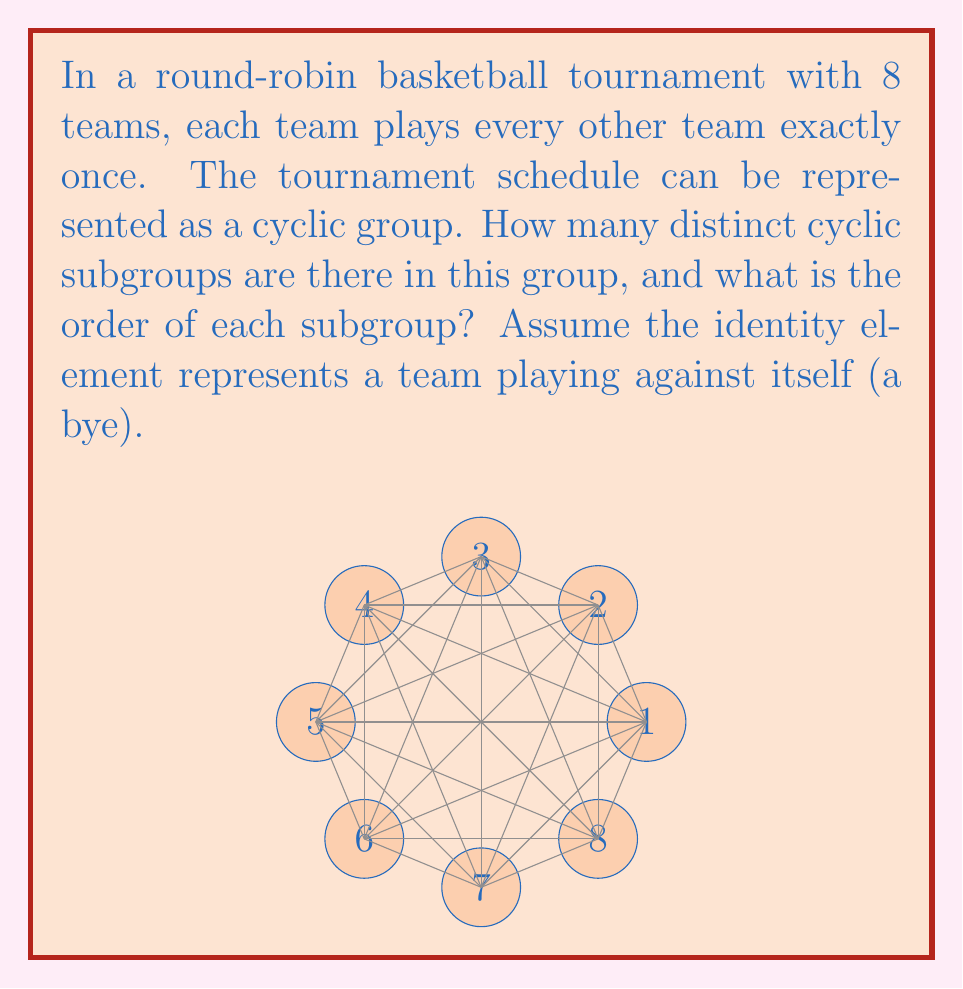Give your solution to this math problem. Let's approach this step-by-step:

1) In a round-robin tournament with 8 teams, we have a total of $\binom{8}{2} = 28$ matches.

2) The cyclic group representing this schedule has order 29 (28 matches + 1 identity element).

3) To find the cyclic subgroups, we need to find the divisors of 29.

4) 29 is a prime number, so its only divisors are 1 and 29.

5) By Lagrange's theorem, the order of a subgroup must divide the order of the group.

6) Therefore, there are only two cyclic subgroups:
   - The trivial subgroup $\{e\}$ of order 1
   - The entire group of order 29

7) The subgroup of order 1 represents the identity element (a team playing against itself or having a bye).

8) The subgroup of order 29 represents the full rotation of the tournament schedule.

In terms of the tournament, this means that the schedule cannot be broken down into smaller repeating patterns. Each team must play every other team once before the pattern repeats.
Answer: 2 cyclic subgroups: orders 1 and 29 